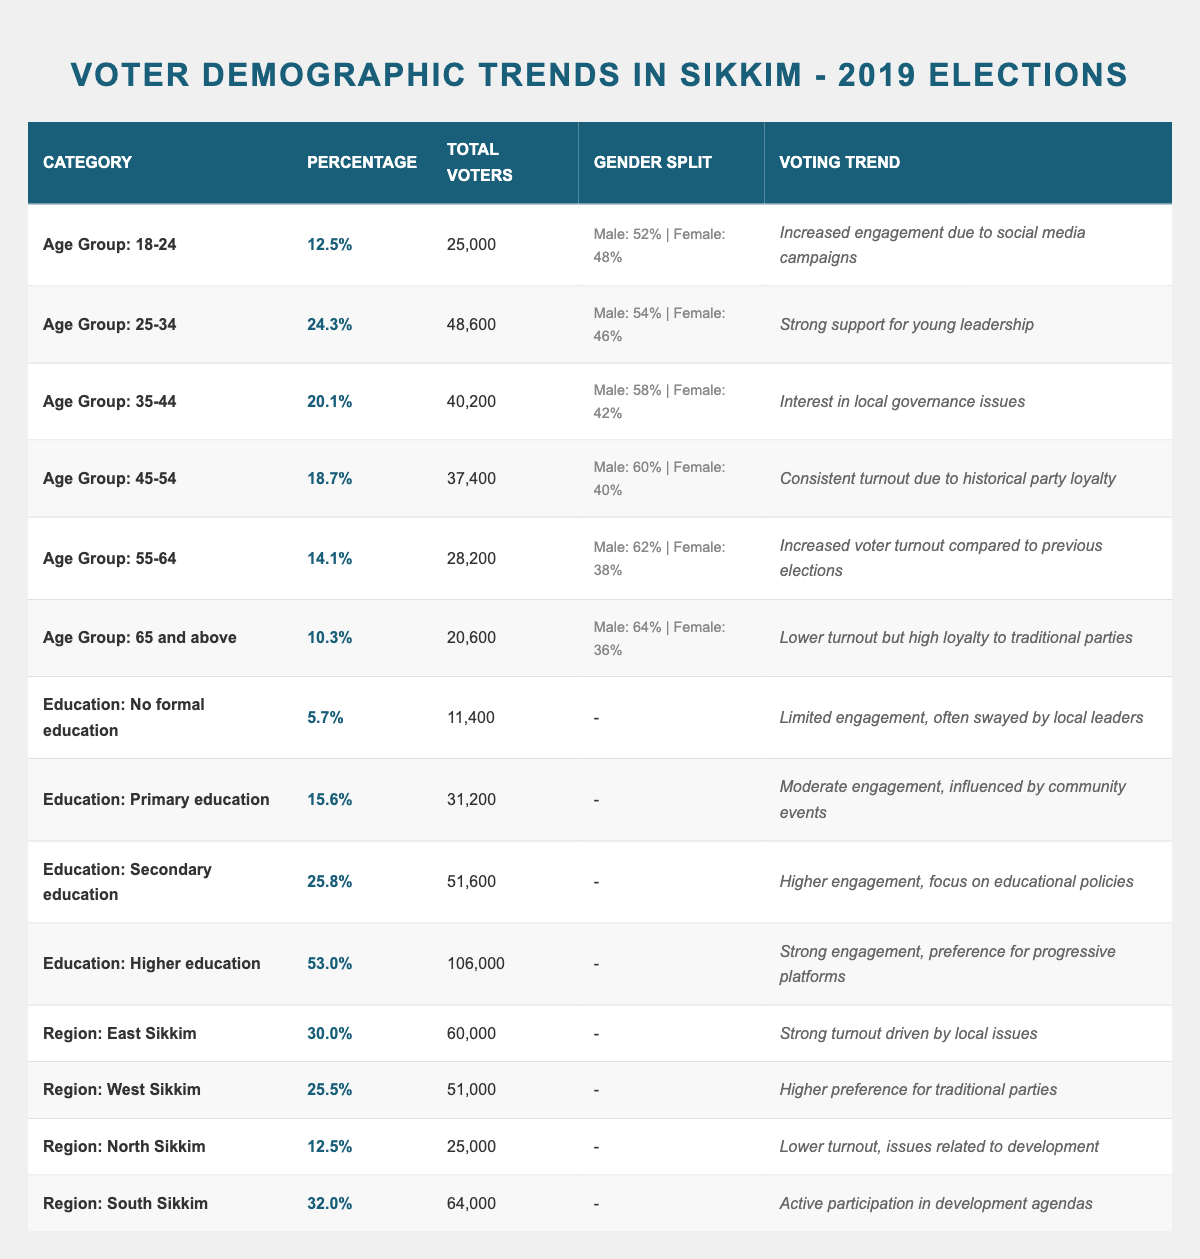What percentage of voters are aged 18-24? From the table, the percentage of voters in the age group 18-24 is listed as 12.5%.
Answer: 12.5% How many total voters come from the age group 45-54? The total voters from the age group 45-54 is provided in the table as 37,400.
Answer: 37,400 Which age group had the highest percentage of voters? Comparing the percentages, the age group with the highest percentage of voters is 25-34 at 24.3%.
Answer: 25-34 What is the total voter count for all age groups combined? By adding the total voters from all age groups (25,000 + 48,600 + 40,200 + 37,400 + 28,200 + 20,600), the total comes to 200,000.
Answer: 200,000 What percentage of voters in the 55-64 age group is male? The male percentage in the 55-64 age group is 62% as stated in the table.
Answer: 62% Is the voting trend for 65 and above age group characterized by high turnout? The voting trend for the 65 and above age group indicates lower turnout but high loyalty to traditional parties, so the statement is false.
Answer: No What is the difference in total voters between the 25-34 age group and the 45-54 age group? The total voters in the 25-34 age group are 48,600, and in the 45-54 age group, it's 37,400. The difference is 48,600 - 37,400 = 11,200.
Answer: 11,200 Which education level has the highest total voter percentage? The highest total voter percentage is for the education level of higher education at 53%.
Answer: 53% What percentage of voters from North Sikkim is lower than the average of all age groups? The average percentage of all age groups can be calculated and compared. The North Sikkim percentage is 12.5%, which is lower than the average of 17.55%. Thus, it is true.
Answer: Yes How much higher is the total voter count for South Sikkim compared to North Sikkim? The total voters for South Sikkim is 64,000 and for North Sikkim is 25,000. The difference is 64,000 - 25,000 = 39,000.
Answer: 39,000 What is the male percentage for the secondary education level? The table does not provide male percentage data for secondary education, so it is not applicable to answer.
Answer: N/A Which voter demographic exhibits the strongest engagement according to the voting trend? The higher education level shows strong engagement with a preference for progressive platforms.
Answer: Higher education 